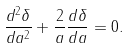<formula> <loc_0><loc_0><loc_500><loc_500>\frac { d ^ { 2 } \delta } { d a ^ { 2 } } + \frac { 2 } { a } \frac { d \delta } { d a } = 0 .</formula> 